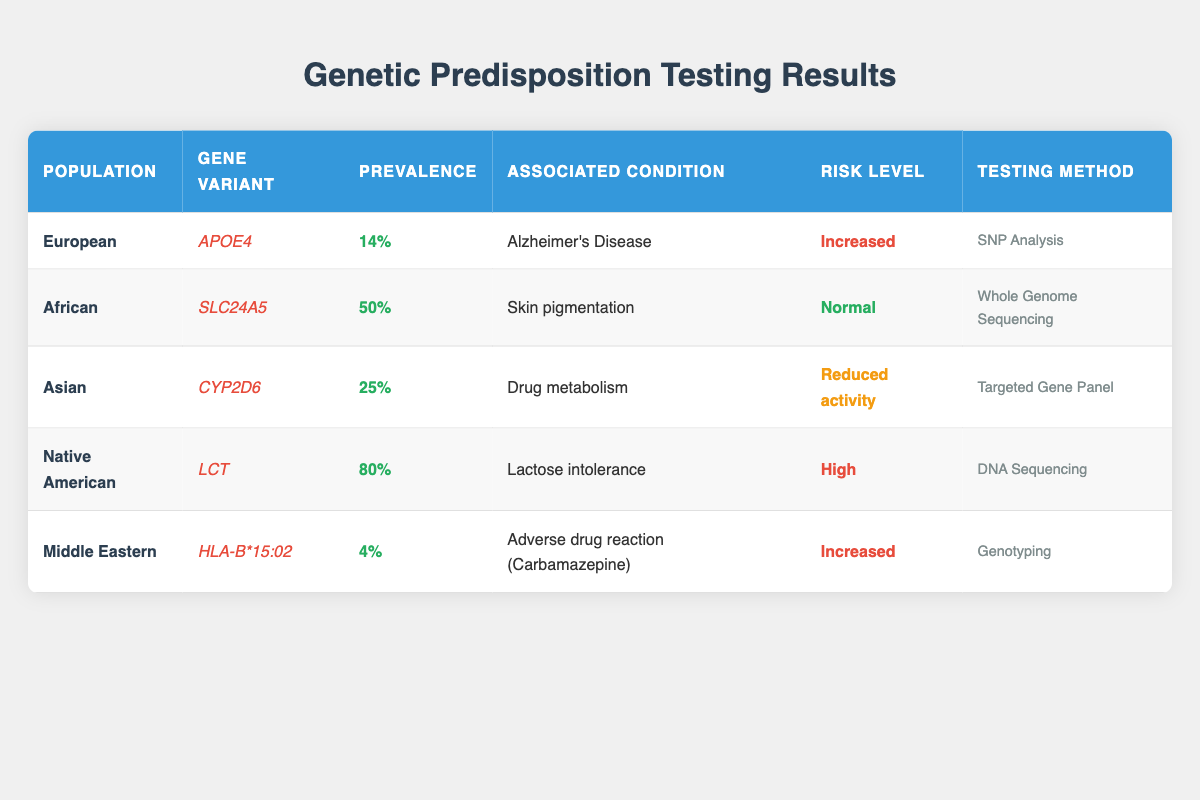What is the prevalence of the gene variant APOE4 in the European population? The table indicates the gene variant APOE4 is associated with the European population, and its prevalence is listed as 14%.
Answer: 14% Which population has the highest prevalence of lactose intolerance, according to the table? The table shows that the Native American population has the gene variant LCT with a prevalence of 80%, which is the highest compared to other populations.
Answer: Native American Is the risk level for the SLC24A5 gene variant in the African population classified as increased? The table shows that the risk level associated with SLC24A5 in the African population is labeled as Normal, not Increased.
Answer: No How many populations have a risk level classified as Increased? By checking the risk levels in the table, both the European (APOE4) and Middle Eastern (HLA-B*15:02) populations are classified with an Increased risk level, making it a total of 2.
Answer: 2 What percentage of the Asian population has reduced activity for the CYP2D6 gene variant? The table lists the Asian population's prevalence of the CYP2D6 gene variant as 25%, which means that 25% have reduced activity associated with it.
Answer: 25% Which gene variant has a risk level classified as High, and in which population is it found? The table states that the LCT gene variant is associated with a High risk level, and it is found in the Native American population.
Answer: LCT, Native American If we were to average the prevalences of all gene variants listed, what would that percentage be? The prevalences to average are 14%, 50%, 25%, 80%, and 4%. Summing these percentages gives 173% (14 + 50 + 25 + 80 + 4). Dividing this sum by the number of entries (5) results in an average prevalence of 34.6%.
Answer: 34.6% Is whole genome sequencing the most common testing method used in these populations? By examining the table, there are five different testing methods listed, and whole genome sequencing is only associated with the African population. Therefore, it is not the most common method.
Answer: No What associated condition is linked to the gene variant HLA-B*15:02 in the Middle Eastern population? The table indicates that the HLA-B*15:02 gene variant is associated with an adverse drug reaction to Carbamazepine in the Middle Eastern population.
Answer: Adverse drug reaction (Carbamazepine) 